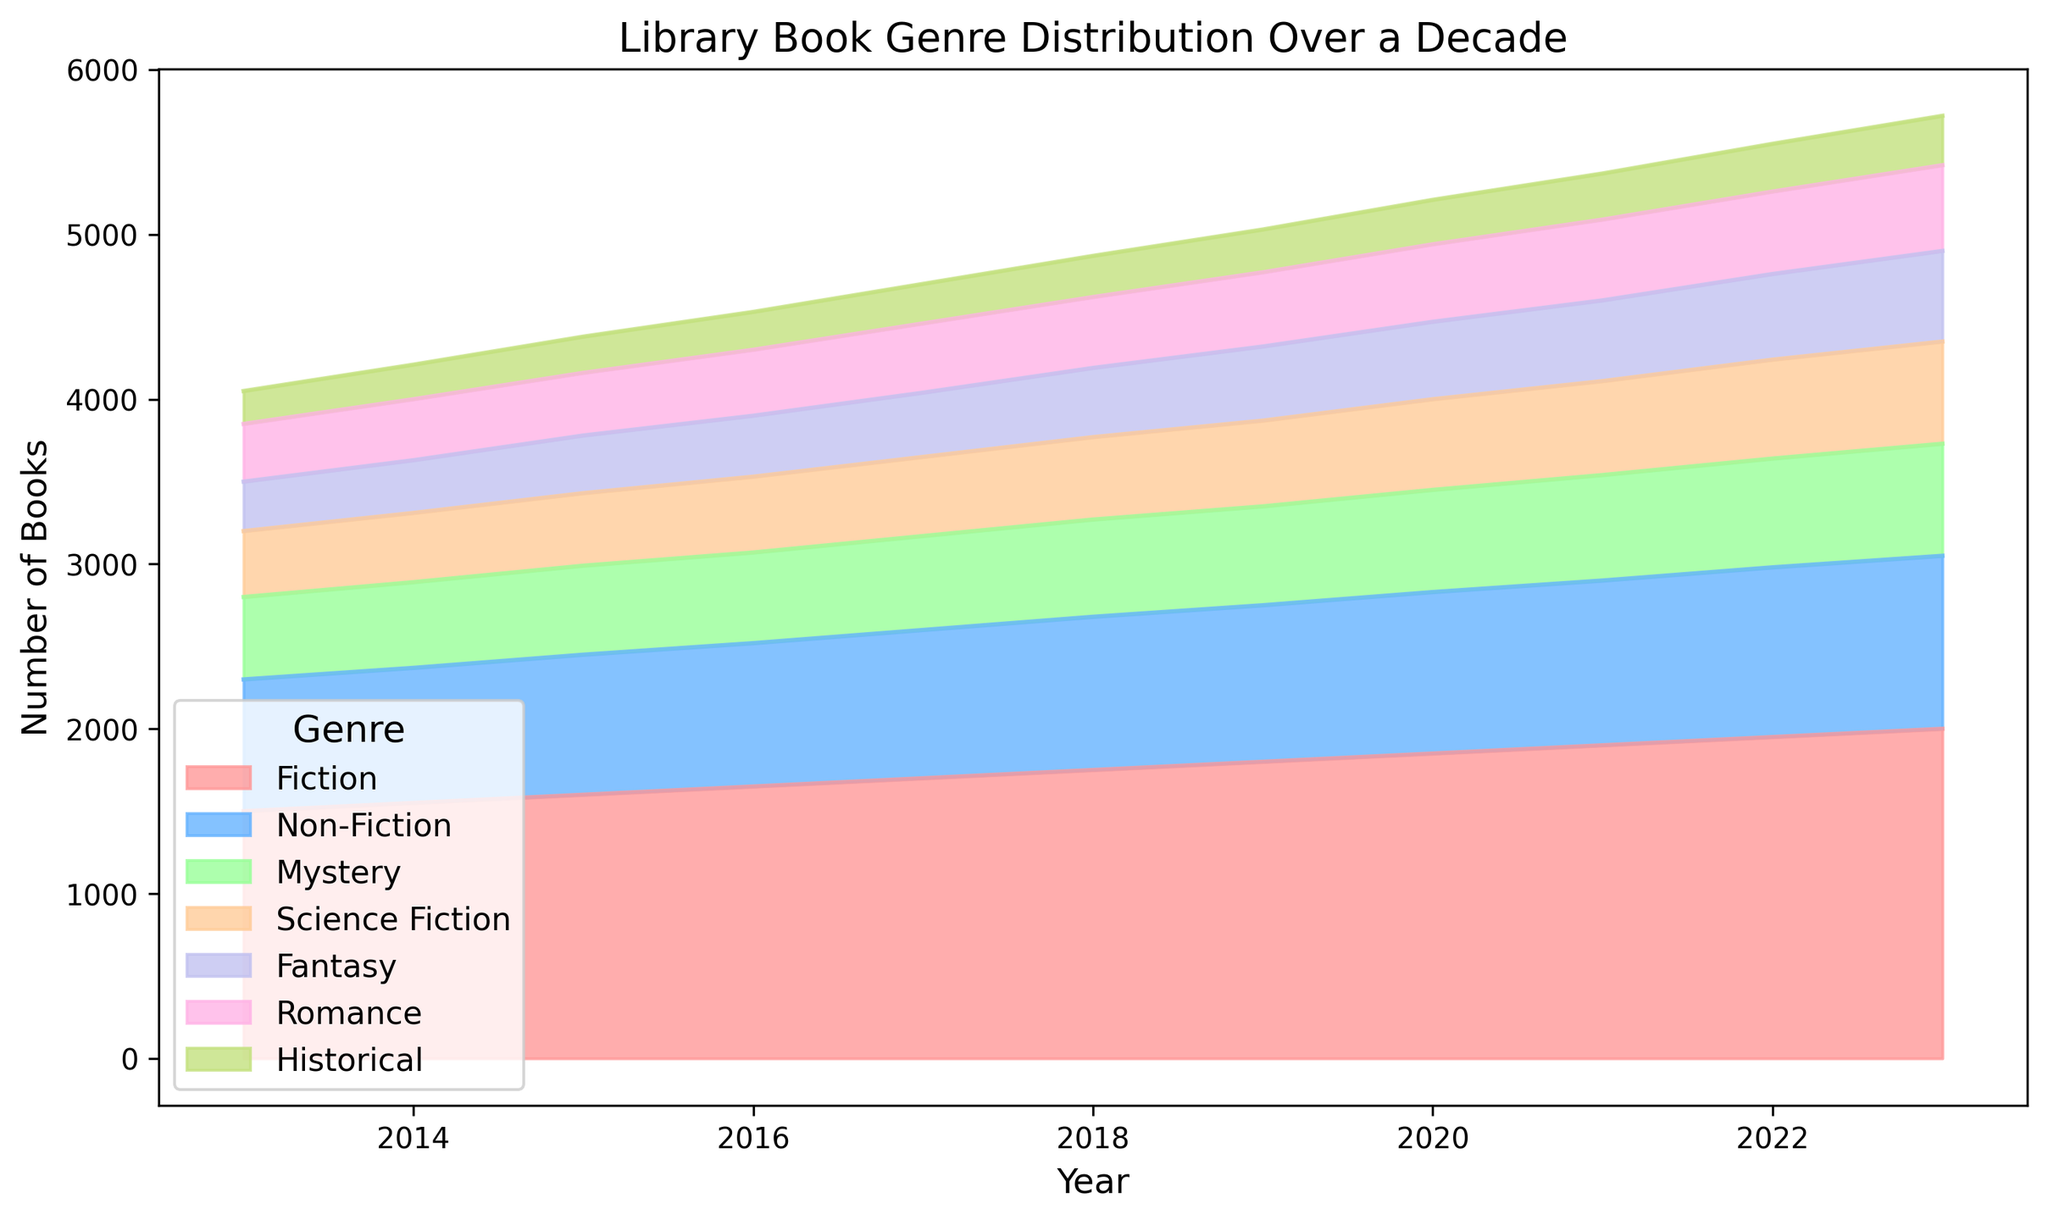What's the total number of books in 2023? To find the total number of books in 2023, add the number of books in each genre for that year: 2000 (Fiction) + 1050 (Non-Fiction) + 680 (Mystery) + 620 (Science Fiction) + 550 (Fantasy) + 520 (Romance) + 300 (Historical). The sum is 2000 + 1050 + 680 + 620 + 550 + 520 + 300 = 5720.
Answer: 5720 What is the average number of Non-Fiction books over the decade? To find the average, sum the Non-Fiction books across all the years and divide by the count of years:
(800 + 820 + 850 + 870 + 900 + 930 + 950 + 980 + 1000 + 1030 + 1050) / 11 = 10180 / 11 = 925.45.
Answer: 925.45 Compare the number of Mystery books in 2019 with the number of Historical books in 2022. Which is greater and by how much? In 2019, the number of Mystery books is 600. In 2022, the number of Historical books is 290. The difference is 600 - 290 = 310. Therefore, the number of Mystery books in 2019 is greater by 310.
Answer: Mystery books in 2019 by 310 From 2015 to 2020, what was the total increase in Fantasy books? Calculate the difference in Fantasy book numbers between 2020 and 2015: 470 (2020) - 350 (2015) = 120.
Answer: 120 How did the number of books in the Romance genre change from 2013 to 2023? Calculate the difference in the number of Romance books between 2023 and 2013: 520 (2023) - 350 (2013) = 170. The number increased by 170 books.
Answer: Increased by 170 